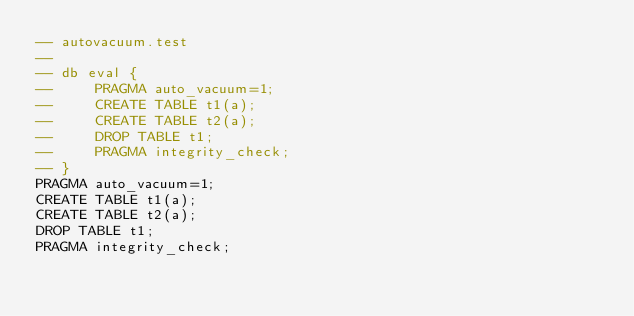Convert code to text. <code><loc_0><loc_0><loc_500><loc_500><_SQL_>-- autovacuum.test
-- 
-- db eval {
--     PRAGMA auto_vacuum=1;
--     CREATE TABLE t1(a);
--     CREATE TABLE t2(a);
--     DROP TABLE t1;
--     PRAGMA integrity_check;
-- }
PRAGMA auto_vacuum=1;
CREATE TABLE t1(a);
CREATE TABLE t2(a);
DROP TABLE t1;
PRAGMA integrity_check;</code> 